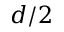<formula> <loc_0><loc_0><loc_500><loc_500>d / 2</formula> 